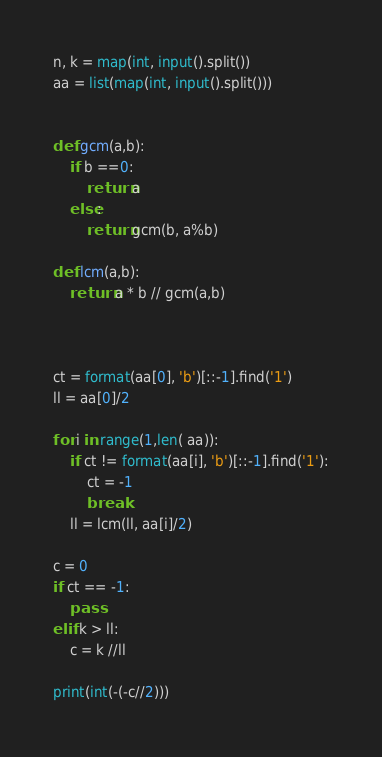<code> <loc_0><loc_0><loc_500><loc_500><_Python_>n, k = map(int, input().split())
aa = list(map(int, input().split()))


def gcm(a,b):
    if b ==0:
        return a
    else:
        return gcm(b, a%b)

def lcm(a,b):
    return a * b // gcm(a,b) 



ct = format(aa[0], 'b')[::-1].find('1')
ll = aa[0]/2

for i in range(1,len( aa)):
    if ct != format(aa[i], 'b')[::-1].find('1'):
        ct = -1
        break
    ll = lcm(ll, aa[i]/2)

c = 0
if ct == -1:
    pass
elif k > ll:
    c = k //ll

print(int(-(-c//2)))



</code> 